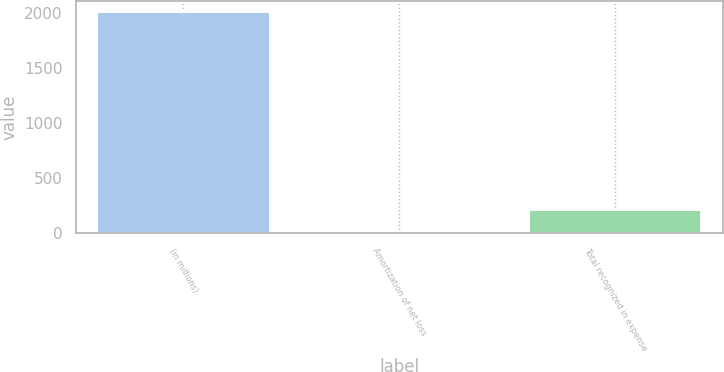<chart> <loc_0><loc_0><loc_500><loc_500><bar_chart><fcel>(in millions)<fcel>Amortization of net loss<fcel>Total recognized in expense<nl><fcel>2011<fcel>13<fcel>212.8<nl></chart> 